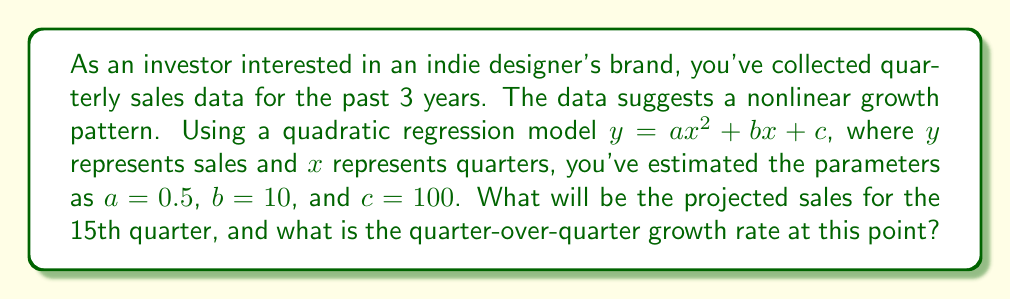Can you solve this math problem? 1. The quadratic regression model is given by:
   $y = ax^2 + bx + c$
   Where $a = 0.5$, $b = 10$, and $c = 100$

2. To find the projected sales for the 15th quarter, substitute $x = 15$ into the equation:
   $y = 0.5(15)^2 + 10(15) + 100$
   $y = 0.5(225) + 150 + 100$
   $y = 112.5 + 150 + 100$
   $y = 362.5$

3. To find the quarter-over-quarter growth rate, we need to calculate the derivative of the function at $x = 15$:
   $\frac{dy}{dx} = 2ax + b$
   $\frac{dy}{dx} = 2(0.5)x + 10$
   $\frac{dy}{dx} = x + 10$

4. Substitute $x = 15$ into the derivative:
   $\frac{dy}{dx}|_{x=15} = 15 + 10 = 25$

5. The growth rate is the derivative divided by the function value at that point:
   Growth Rate = $\frac{\frac{dy}{dx}|_{x=15}}{y|_{x=15}} = \frac{25}{362.5} \approx 0.069$ or 6.9%
Answer: Projected sales: $362.5; Quarter-over-quarter growth rate: 6.9% 